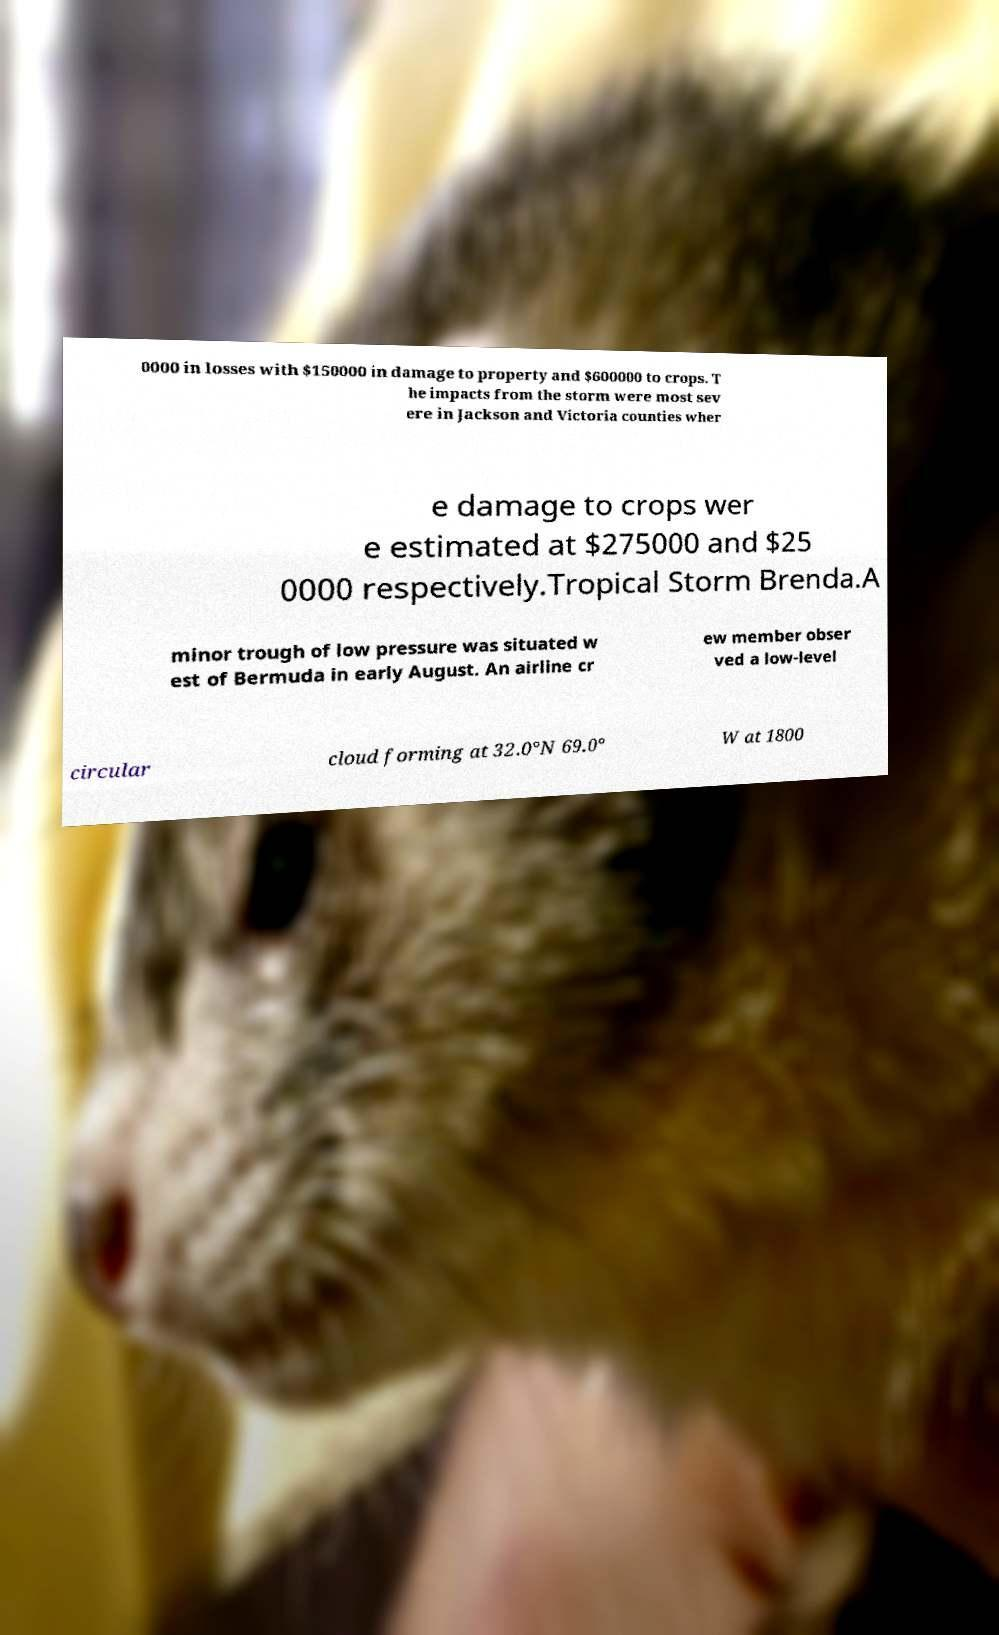For documentation purposes, I need the text within this image transcribed. Could you provide that? 0000 in losses with $150000 in damage to property and $600000 to crops. T he impacts from the storm were most sev ere in Jackson and Victoria counties wher e damage to crops wer e estimated at $275000 and $25 0000 respectively.Tropical Storm Brenda.A minor trough of low pressure was situated w est of Bermuda in early August. An airline cr ew member obser ved a low-level circular cloud forming at 32.0°N 69.0° W at 1800 